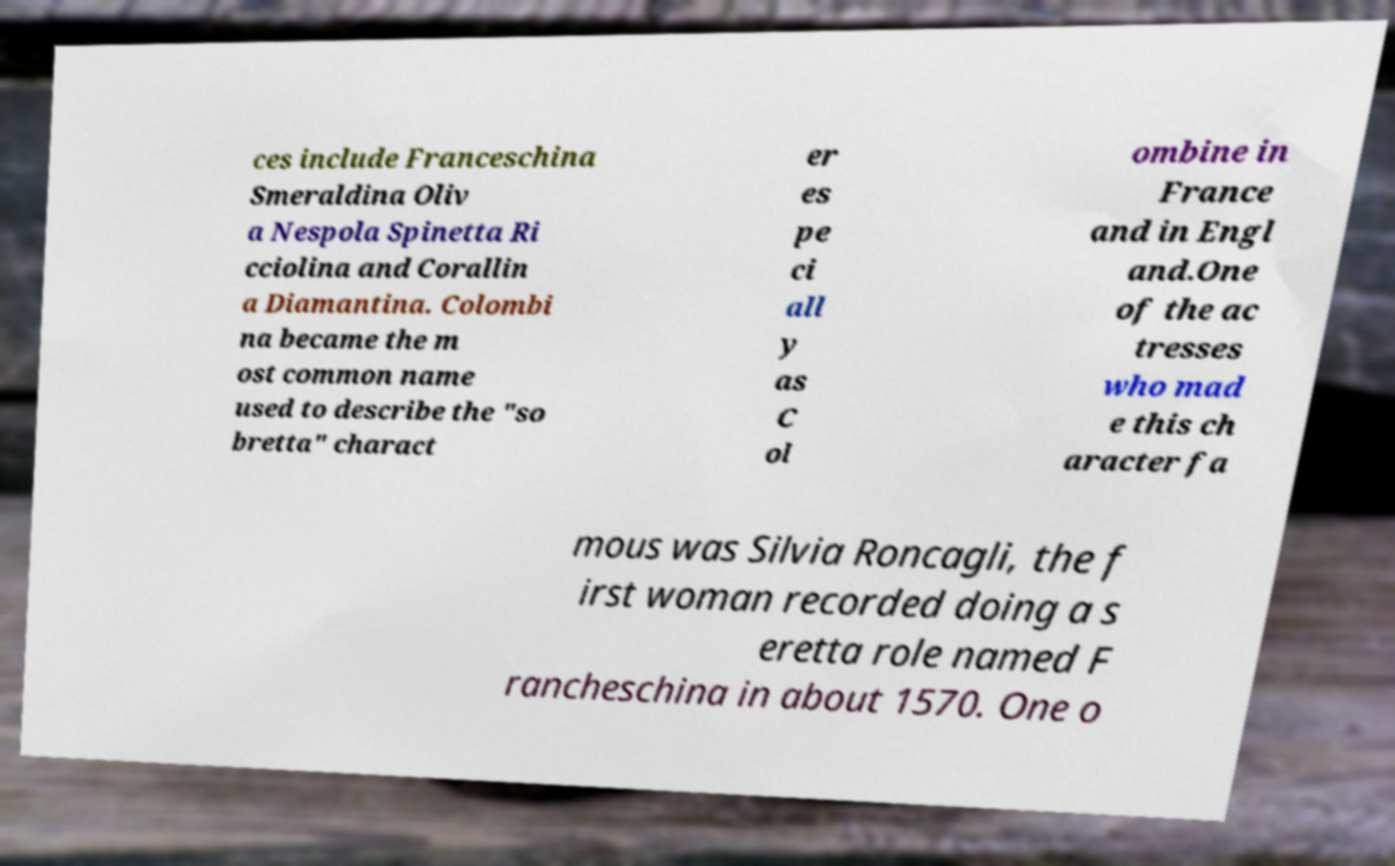Please identify and transcribe the text found in this image. ces include Franceschina Smeraldina Oliv a Nespola Spinetta Ri cciolina and Corallin a Diamantina. Colombi na became the m ost common name used to describe the "so bretta" charact er es pe ci all y as C ol ombine in France and in Engl and.One of the ac tresses who mad e this ch aracter fa mous was Silvia Roncagli, the f irst woman recorded doing a s eretta role named F rancheschina in about 1570. One o 